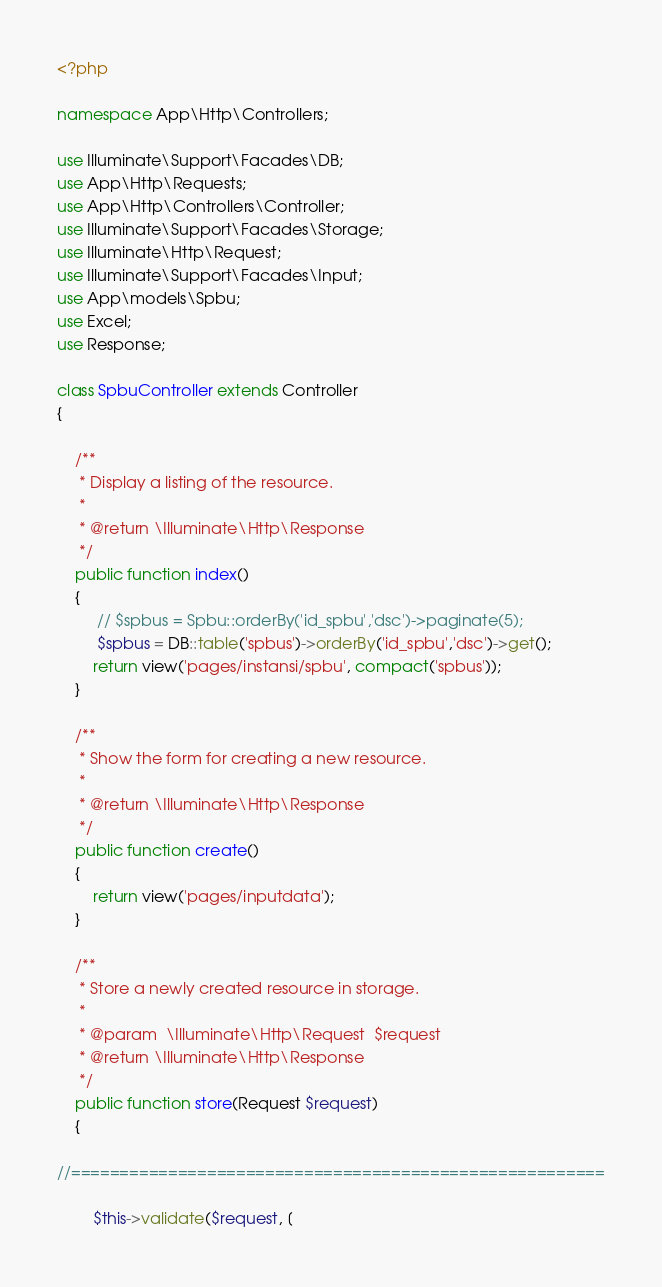<code> <loc_0><loc_0><loc_500><loc_500><_PHP_><?php

namespace App\Http\Controllers;

use Illuminate\Support\Facades\DB;
use App\Http\Requests;
use App\Http\Controllers\Controller;
use Illuminate\Support\Facades\Storage;
use Illuminate\Http\Request;
use Illuminate\Support\Facades\Input;
use App\models\Spbu;
use Excel;
use Response;

class SpbuController extends Controller
{

    /**
     * Display a listing of the resource.
     *
     * @return \Illuminate\Http\Response
     */
    public function index()
    {
         // $spbus = Spbu::orderBy('id_spbu','dsc')->paginate(5);
         $spbus = DB::table('spbus')->orderBy('id_spbu','dsc')->get();
        return view('pages/instansi/spbu', compact('spbus'));
    }

    /**
     * Show the form for creating a new resource.
     *
     * @return \Illuminate\Http\Response
     */
    public function create()
    {
        return view('pages/inputdata');
    }

    /**
     * Store a newly created resource in storage.
     *
     * @param  \Illuminate\Http\Request  $request
     * @return \Illuminate\Http\Response
     */
    public function store(Request $request)
    {

//=======================================================

        $this->validate($request, [</code> 